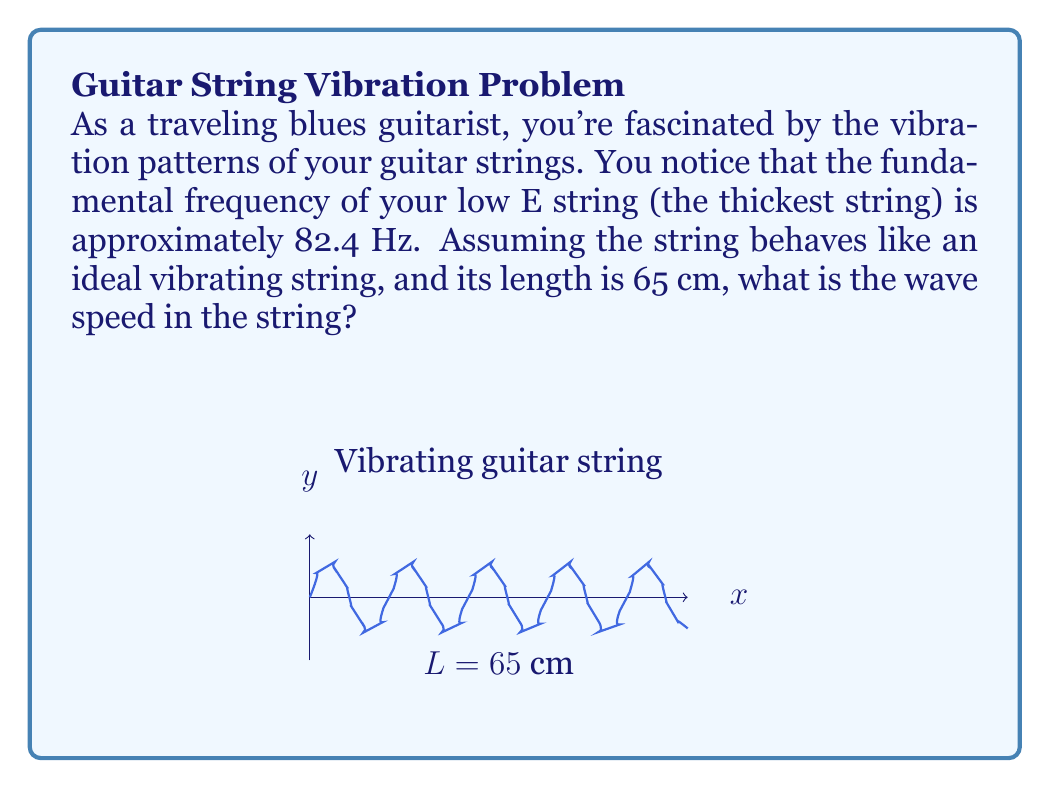Solve this math problem. Let's approach this step-by-step using the wave equation for an ideal vibrating string:

1) The wave equation for a vibrating string is:

   $$v = f\lambda$$

   where $v$ is the wave speed, $f$ is the frequency, and $\lambda$ is the wavelength.

2) For the fundamental frequency, the wavelength is twice the length of the string:

   $$\lambda = 2L$$

   where $L$ is the length of the string.

3) We're given that $L = 65$ cm $= 0.65$ m, so:

   $$\lambda = 2 \times 0.65 = 1.3 \text{ m}$$

4) We're also given that the fundamental frequency $f = 82.4$ Hz.

5) Now we can substitute these values into the wave equation:

   $$v = f\lambda = 82.4 \text{ Hz} \times 1.3 \text{ m}$$

6) Calculating this:

   $$v = 107.12 \text{ m/s}$$

Therefore, the wave speed in the string is approximately 107.1 m/s.
Answer: 107.1 m/s 